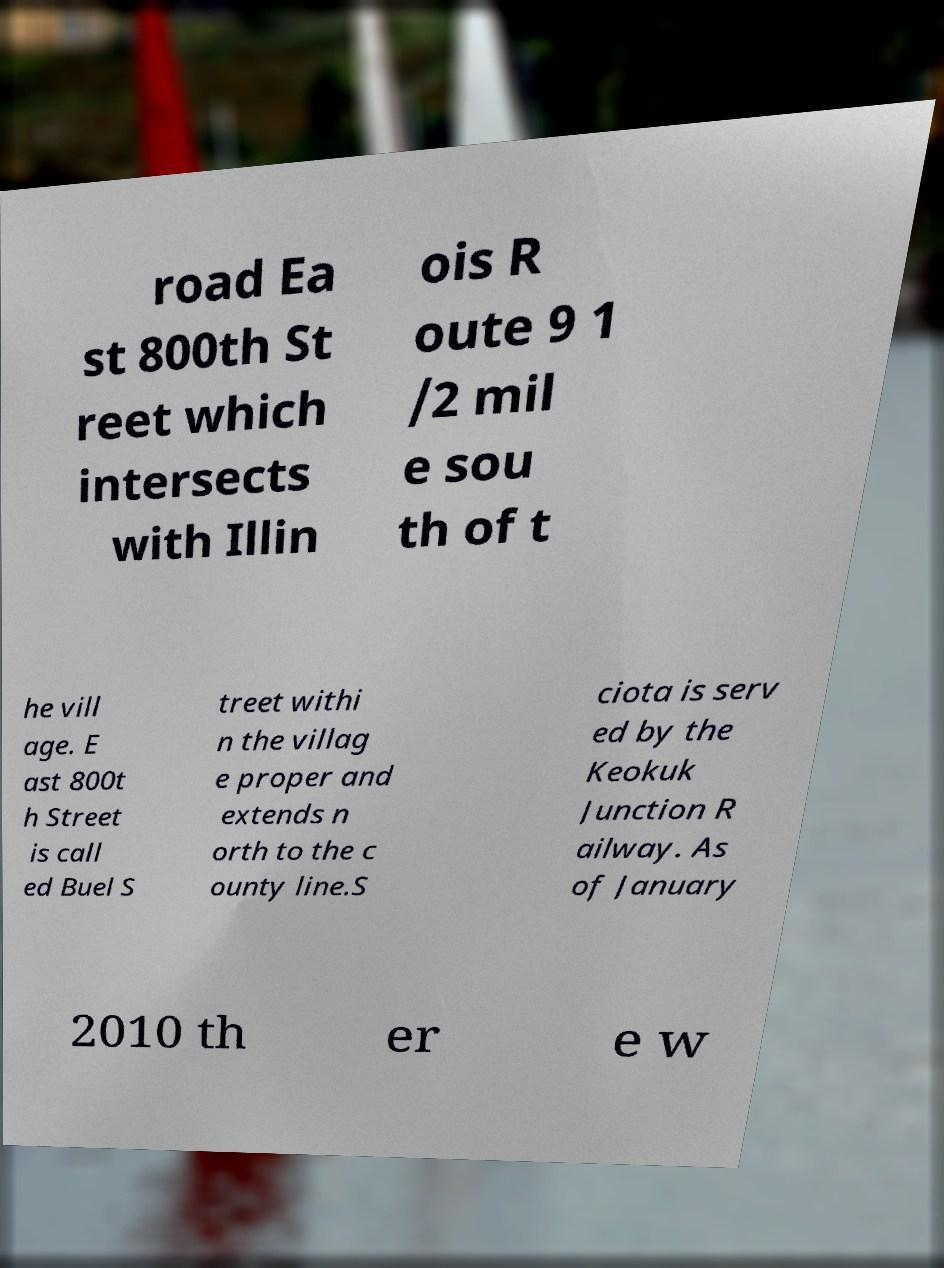Could you extract and type out the text from this image? road Ea st 800th St reet which intersects with Illin ois R oute 9 1 /2 mil e sou th of t he vill age. E ast 800t h Street is call ed Buel S treet withi n the villag e proper and extends n orth to the c ounty line.S ciota is serv ed by the Keokuk Junction R ailway. As of January 2010 th er e w 